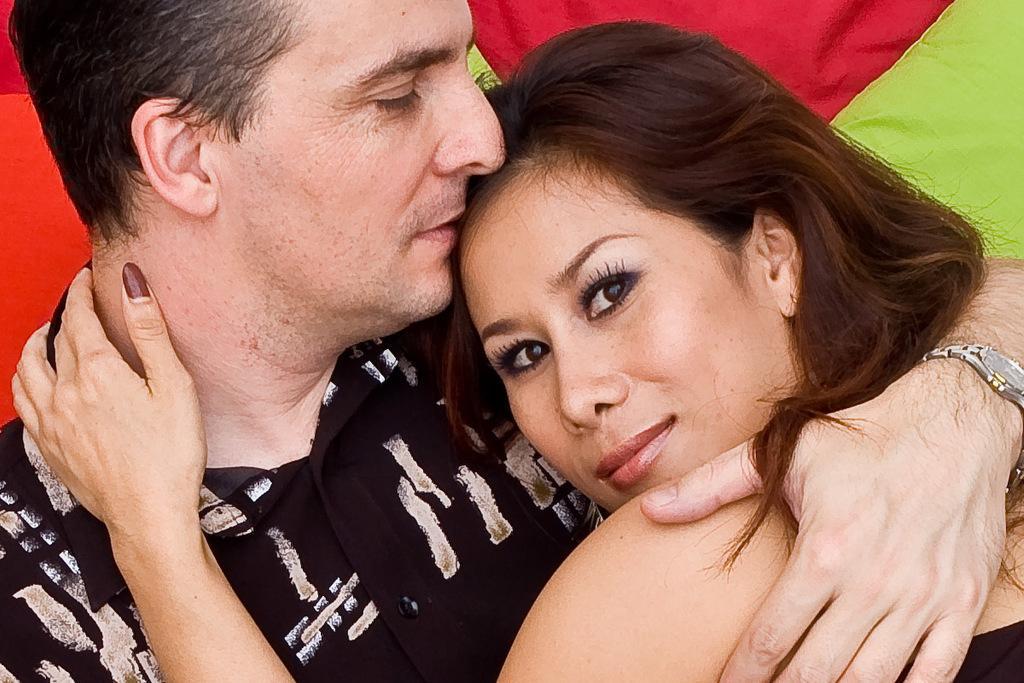Describe this image in one or two sentences. In this image I can see a person wearing black shirt and a woman wearing black colored dress. I can see the man is wearing a watch. In the background I can see green, red and orange colored surface. 